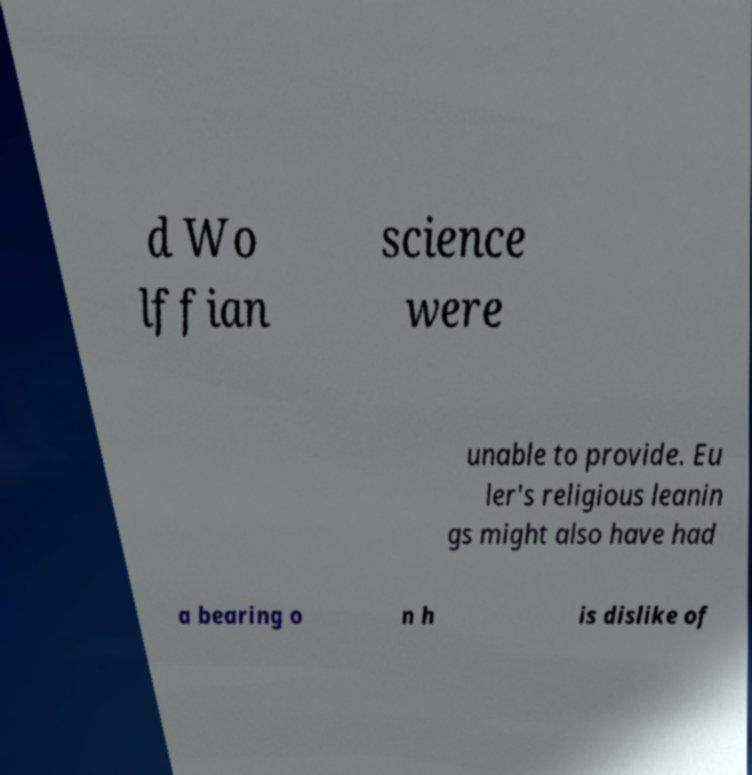I need the written content from this picture converted into text. Can you do that? d Wo lffian science were unable to provide. Eu ler's religious leanin gs might also have had a bearing o n h is dislike of 